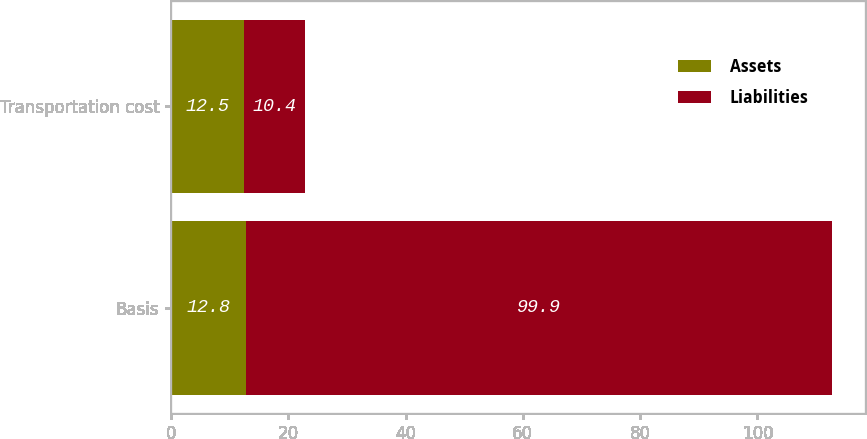Convert chart. <chart><loc_0><loc_0><loc_500><loc_500><stacked_bar_chart><ecel><fcel>Basis<fcel>Transportation cost<nl><fcel>Assets<fcel>12.8<fcel>12.5<nl><fcel>Liabilities<fcel>99.9<fcel>10.4<nl></chart> 